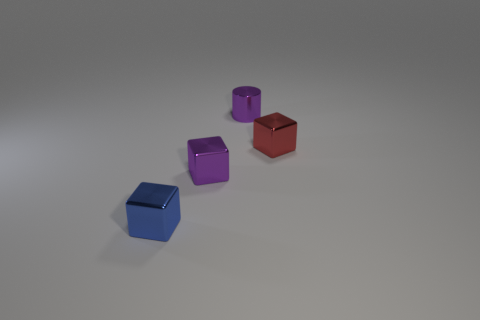Add 4 small shiny cylinders. How many objects exist? 8 Subtract all cylinders. How many objects are left? 3 Subtract all big cylinders. Subtract all red metallic blocks. How many objects are left? 3 Add 1 blue cubes. How many blue cubes are left? 2 Add 2 purple shiny objects. How many purple shiny objects exist? 4 Subtract 0 brown cylinders. How many objects are left? 4 